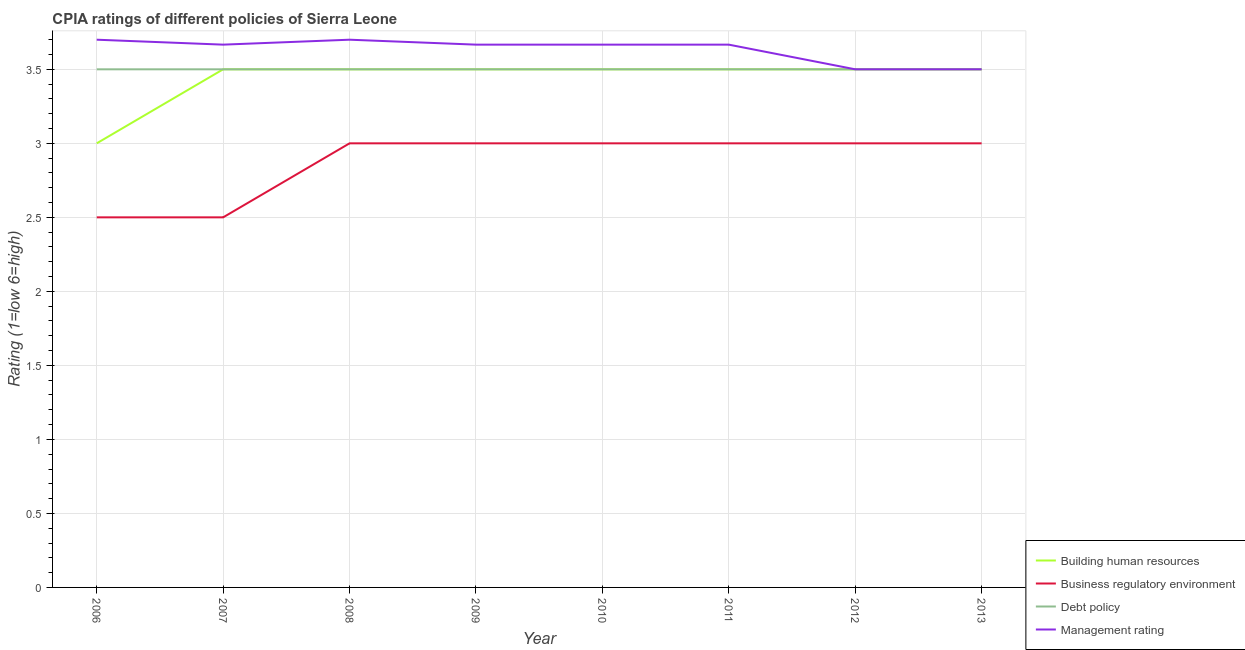How many different coloured lines are there?
Keep it short and to the point. 4. Does the line corresponding to cpia rating of business regulatory environment intersect with the line corresponding to cpia rating of debt policy?
Keep it short and to the point. No. Across all years, what is the maximum cpia rating of debt policy?
Ensure brevity in your answer.  3.5. In which year was the cpia rating of business regulatory environment minimum?
Offer a terse response. 2006. What is the difference between the cpia rating of management in 2009 and the cpia rating of business regulatory environment in 2007?
Provide a short and direct response. 1.17. What is the average cpia rating of management per year?
Your answer should be very brief. 3.63. What is the ratio of the cpia rating of business regulatory environment in 2007 to that in 2011?
Offer a terse response. 0.83. Is the cpia rating of debt policy in 2006 less than that in 2009?
Provide a succinct answer. No. Is the difference between the cpia rating of management in 2010 and 2012 greater than the difference between the cpia rating of debt policy in 2010 and 2012?
Keep it short and to the point. Yes. What is the difference between the highest and the second highest cpia rating of building human resources?
Your answer should be very brief. 0. What is the difference between the highest and the lowest cpia rating of management?
Ensure brevity in your answer.  0.2. Is the sum of the cpia rating of business regulatory environment in 2006 and 2011 greater than the maximum cpia rating of building human resources across all years?
Offer a terse response. Yes. Is it the case that in every year, the sum of the cpia rating of building human resources and cpia rating of business regulatory environment is greater than the cpia rating of debt policy?
Your response must be concise. Yes. Is the cpia rating of business regulatory environment strictly greater than the cpia rating of building human resources over the years?
Your response must be concise. No. Is the cpia rating of business regulatory environment strictly less than the cpia rating of building human resources over the years?
Provide a short and direct response. Yes. How many years are there in the graph?
Your answer should be very brief. 8. Are the values on the major ticks of Y-axis written in scientific E-notation?
Give a very brief answer. No. How many legend labels are there?
Your answer should be very brief. 4. How are the legend labels stacked?
Offer a terse response. Vertical. What is the title of the graph?
Give a very brief answer. CPIA ratings of different policies of Sierra Leone. Does "Belgium" appear as one of the legend labels in the graph?
Provide a succinct answer. No. What is the label or title of the X-axis?
Provide a short and direct response. Year. What is the label or title of the Y-axis?
Provide a succinct answer. Rating (1=low 6=high). What is the Rating (1=low 6=high) of Business regulatory environment in 2006?
Offer a terse response. 2.5. What is the Rating (1=low 6=high) in Management rating in 2006?
Make the answer very short. 3.7. What is the Rating (1=low 6=high) in Business regulatory environment in 2007?
Offer a terse response. 2.5. What is the Rating (1=low 6=high) of Management rating in 2007?
Give a very brief answer. 3.67. What is the Rating (1=low 6=high) of Building human resources in 2008?
Make the answer very short. 3.5. What is the Rating (1=low 6=high) in Business regulatory environment in 2008?
Your answer should be very brief. 3. What is the Rating (1=low 6=high) in Building human resources in 2009?
Your answer should be compact. 3.5. What is the Rating (1=low 6=high) in Debt policy in 2009?
Your answer should be very brief. 3.5. What is the Rating (1=low 6=high) in Management rating in 2009?
Your answer should be very brief. 3.67. What is the Rating (1=low 6=high) of Management rating in 2010?
Give a very brief answer. 3.67. What is the Rating (1=low 6=high) in Business regulatory environment in 2011?
Give a very brief answer. 3. What is the Rating (1=low 6=high) of Debt policy in 2011?
Provide a succinct answer. 3.5. What is the Rating (1=low 6=high) of Management rating in 2011?
Give a very brief answer. 3.67. What is the Rating (1=low 6=high) in Building human resources in 2012?
Offer a very short reply. 3.5. What is the Rating (1=low 6=high) of Business regulatory environment in 2012?
Offer a terse response. 3. What is the Rating (1=low 6=high) of Debt policy in 2012?
Make the answer very short. 3.5. What is the Rating (1=low 6=high) of Management rating in 2012?
Offer a terse response. 3.5. What is the Rating (1=low 6=high) of Building human resources in 2013?
Provide a short and direct response. 3.5. What is the Rating (1=low 6=high) of Business regulatory environment in 2013?
Give a very brief answer. 3. What is the Rating (1=low 6=high) in Management rating in 2013?
Keep it short and to the point. 3.5. Across all years, what is the maximum Rating (1=low 6=high) in Building human resources?
Make the answer very short. 3.5. Across all years, what is the maximum Rating (1=low 6=high) of Business regulatory environment?
Provide a short and direct response. 3. Across all years, what is the maximum Rating (1=low 6=high) in Debt policy?
Provide a short and direct response. 3.5. Across all years, what is the maximum Rating (1=low 6=high) of Management rating?
Your response must be concise. 3.7. Across all years, what is the minimum Rating (1=low 6=high) of Debt policy?
Offer a very short reply. 3.5. Across all years, what is the minimum Rating (1=low 6=high) in Management rating?
Provide a short and direct response. 3.5. What is the total Rating (1=low 6=high) in Building human resources in the graph?
Your answer should be compact. 27.5. What is the total Rating (1=low 6=high) in Business regulatory environment in the graph?
Keep it short and to the point. 23. What is the total Rating (1=low 6=high) in Debt policy in the graph?
Keep it short and to the point. 28. What is the total Rating (1=low 6=high) in Management rating in the graph?
Your response must be concise. 29.07. What is the difference between the Rating (1=low 6=high) of Business regulatory environment in 2006 and that in 2007?
Give a very brief answer. 0. What is the difference between the Rating (1=low 6=high) in Management rating in 2006 and that in 2007?
Offer a terse response. 0.03. What is the difference between the Rating (1=low 6=high) in Business regulatory environment in 2006 and that in 2008?
Ensure brevity in your answer.  -0.5. What is the difference between the Rating (1=low 6=high) in Management rating in 2006 and that in 2008?
Your answer should be very brief. 0. What is the difference between the Rating (1=low 6=high) of Building human resources in 2006 and that in 2009?
Keep it short and to the point. -0.5. What is the difference between the Rating (1=low 6=high) of Business regulatory environment in 2006 and that in 2009?
Give a very brief answer. -0.5. What is the difference between the Rating (1=low 6=high) in Debt policy in 2006 and that in 2009?
Offer a very short reply. 0. What is the difference between the Rating (1=low 6=high) of Management rating in 2006 and that in 2009?
Make the answer very short. 0.03. What is the difference between the Rating (1=low 6=high) in Building human resources in 2006 and that in 2010?
Give a very brief answer. -0.5. What is the difference between the Rating (1=low 6=high) of Business regulatory environment in 2006 and that in 2010?
Your answer should be very brief. -0.5. What is the difference between the Rating (1=low 6=high) in Business regulatory environment in 2006 and that in 2011?
Offer a terse response. -0.5. What is the difference between the Rating (1=low 6=high) in Management rating in 2006 and that in 2011?
Provide a succinct answer. 0.03. What is the difference between the Rating (1=low 6=high) of Building human resources in 2006 and that in 2012?
Your answer should be compact. -0.5. What is the difference between the Rating (1=low 6=high) of Business regulatory environment in 2006 and that in 2012?
Your response must be concise. -0.5. What is the difference between the Rating (1=low 6=high) in Debt policy in 2006 and that in 2012?
Provide a succinct answer. 0. What is the difference between the Rating (1=low 6=high) in Building human resources in 2006 and that in 2013?
Your answer should be very brief. -0.5. What is the difference between the Rating (1=low 6=high) of Business regulatory environment in 2006 and that in 2013?
Provide a succinct answer. -0.5. What is the difference between the Rating (1=low 6=high) in Management rating in 2006 and that in 2013?
Your answer should be very brief. 0.2. What is the difference between the Rating (1=low 6=high) in Building human resources in 2007 and that in 2008?
Provide a short and direct response. 0. What is the difference between the Rating (1=low 6=high) in Debt policy in 2007 and that in 2008?
Your response must be concise. 0. What is the difference between the Rating (1=low 6=high) in Management rating in 2007 and that in 2008?
Provide a succinct answer. -0.03. What is the difference between the Rating (1=low 6=high) in Building human resources in 2007 and that in 2009?
Offer a terse response. 0. What is the difference between the Rating (1=low 6=high) of Business regulatory environment in 2007 and that in 2009?
Keep it short and to the point. -0.5. What is the difference between the Rating (1=low 6=high) in Building human resources in 2007 and that in 2010?
Your response must be concise. 0. What is the difference between the Rating (1=low 6=high) of Debt policy in 2007 and that in 2010?
Your answer should be very brief. 0. What is the difference between the Rating (1=low 6=high) in Management rating in 2007 and that in 2010?
Your response must be concise. 0. What is the difference between the Rating (1=low 6=high) in Management rating in 2007 and that in 2011?
Make the answer very short. 0. What is the difference between the Rating (1=low 6=high) of Debt policy in 2007 and that in 2012?
Your response must be concise. 0. What is the difference between the Rating (1=low 6=high) in Management rating in 2007 and that in 2012?
Keep it short and to the point. 0.17. What is the difference between the Rating (1=low 6=high) of Business regulatory environment in 2007 and that in 2013?
Your response must be concise. -0.5. What is the difference between the Rating (1=low 6=high) of Building human resources in 2008 and that in 2009?
Your response must be concise. 0. What is the difference between the Rating (1=low 6=high) in Business regulatory environment in 2008 and that in 2009?
Provide a succinct answer. 0. What is the difference between the Rating (1=low 6=high) in Management rating in 2008 and that in 2009?
Provide a short and direct response. 0.03. What is the difference between the Rating (1=low 6=high) in Debt policy in 2008 and that in 2010?
Provide a short and direct response. 0. What is the difference between the Rating (1=low 6=high) in Building human resources in 2008 and that in 2011?
Provide a short and direct response. 0. What is the difference between the Rating (1=low 6=high) in Business regulatory environment in 2008 and that in 2011?
Offer a terse response. 0. What is the difference between the Rating (1=low 6=high) of Management rating in 2008 and that in 2011?
Your answer should be compact. 0.03. What is the difference between the Rating (1=low 6=high) in Business regulatory environment in 2008 and that in 2012?
Keep it short and to the point. 0. What is the difference between the Rating (1=low 6=high) in Building human resources in 2008 and that in 2013?
Your response must be concise. 0. What is the difference between the Rating (1=low 6=high) in Business regulatory environment in 2008 and that in 2013?
Give a very brief answer. 0. What is the difference between the Rating (1=low 6=high) of Management rating in 2008 and that in 2013?
Offer a very short reply. 0.2. What is the difference between the Rating (1=low 6=high) in Building human resources in 2009 and that in 2010?
Give a very brief answer. 0. What is the difference between the Rating (1=low 6=high) of Building human resources in 2009 and that in 2011?
Offer a terse response. 0. What is the difference between the Rating (1=low 6=high) in Debt policy in 2009 and that in 2011?
Provide a short and direct response. 0. What is the difference between the Rating (1=low 6=high) of Management rating in 2009 and that in 2011?
Make the answer very short. 0. What is the difference between the Rating (1=low 6=high) in Building human resources in 2009 and that in 2012?
Ensure brevity in your answer.  0. What is the difference between the Rating (1=low 6=high) in Business regulatory environment in 2009 and that in 2012?
Make the answer very short. 0. What is the difference between the Rating (1=low 6=high) in Management rating in 2009 and that in 2012?
Provide a short and direct response. 0.17. What is the difference between the Rating (1=low 6=high) in Building human resources in 2009 and that in 2013?
Provide a succinct answer. 0. What is the difference between the Rating (1=low 6=high) of Business regulatory environment in 2009 and that in 2013?
Your answer should be very brief. 0. What is the difference between the Rating (1=low 6=high) of Building human resources in 2010 and that in 2011?
Give a very brief answer. 0. What is the difference between the Rating (1=low 6=high) of Business regulatory environment in 2010 and that in 2011?
Ensure brevity in your answer.  0. What is the difference between the Rating (1=low 6=high) of Building human resources in 2010 and that in 2012?
Provide a short and direct response. 0. What is the difference between the Rating (1=low 6=high) in Business regulatory environment in 2010 and that in 2012?
Make the answer very short. 0. What is the difference between the Rating (1=low 6=high) of Building human resources in 2010 and that in 2013?
Your response must be concise. 0. What is the difference between the Rating (1=low 6=high) in Business regulatory environment in 2010 and that in 2013?
Your answer should be very brief. 0. What is the difference between the Rating (1=low 6=high) of Building human resources in 2011 and that in 2012?
Offer a very short reply. 0. What is the difference between the Rating (1=low 6=high) of Business regulatory environment in 2011 and that in 2012?
Provide a succinct answer. 0. What is the difference between the Rating (1=low 6=high) in Debt policy in 2011 and that in 2012?
Your answer should be compact. 0. What is the difference between the Rating (1=low 6=high) in Management rating in 2011 and that in 2012?
Your answer should be very brief. 0.17. What is the difference between the Rating (1=low 6=high) in Building human resources in 2011 and that in 2013?
Provide a short and direct response. 0. What is the difference between the Rating (1=low 6=high) in Business regulatory environment in 2011 and that in 2013?
Make the answer very short. 0. What is the difference between the Rating (1=low 6=high) of Debt policy in 2011 and that in 2013?
Provide a succinct answer. 0. What is the difference between the Rating (1=low 6=high) in Building human resources in 2012 and that in 2013?
Your response must be concise. 0. What is the difference between the Rating (1=low 6=high) in Business regulatory environment in 2012 and that in 2013?
Offer a very short reply. 0. What is the difference between the Rating (1=low 6=high) in Debt policy in 2012 and that in 2013?
Keep it short and to the point. 0. What is the difference between the Rating (1=low 6=high) of Building human resources in 2006 and the Rating (1=low 6=high) of Management rating in 2007?
Your response must be concise. -0.67. What is the difference between the Rating (1=low 6=high) of Business regulatory environment in 2006 and the Rating (1=low 6=high) of Debt policy in 2007?
Ensure brevity in your answer.  -1. What is the difference between the Rating (1=low 6=high) in Business regulatory environment in 2006 and the Rating (1=low 6=high) in Management rating in 2007?
Give a very brief answer. -1.17. What is the difference between the Rating (1=low 6=high) of Building human resources in 2006 and the Rating (1=low 6=high) of Management rating in 2008?
Offer a very short reply. -0.7. What is the difference between the Rating (1=low 6=high) of Business regulatory environment in 2006 and the Rating (1=low 6=high) of Debt policy in 2008?
Offer a terse response. -1. What is the difference between the Rating (1=low 6=high) of Debt policy in 2006 and the Rating (1=low 6=high) of Management rating in 2008?
Make the answer very short. -0.2. What is the difference between the Rating (1=low 6=high) in Building human resources in 2006 and the Rating (1=low 6=high) in Debt policy in 2009?
Offer a terse response. -0.5. What is the difference between the Rating (1=low 6=high) of Building human resources in 2006 and the Rating (1=low 6=high) of Management rating in 2009?
Give a very brief answer. -0.67. What is the difference between the Rating (1=low 6=high) in Business regulatory environment in 2006 and the Rating (1=low 6=high) in Debt policy in 2009?
Keep it short and to the point. -1. What is the difference between the Rating (1=low 6=high) of Business regulatory environment in 2006 and the Rating (1=low 6=high) of Management rating in 2009?
Your answer should be very brief. -1.17. What is the difference between the Rating (1=low 6=high) of Debt policy in 2006 and the Rating (1=low 6=high) of Management rating in 2009?
Ensure brevity in your answer.  -0.17. What is the difference between the Rating (1=low 6=high) in Building human resources in 2006 and the Rating (1=low 6=high) in Debt policy in 2010?
Make the answer very short. -0.5. What is the difference between the Rating (1=low 6=high) in Business regulatory environment in 2006 and the Rating (1=low 6=high) in Management rating in 2010?
Your response must be concise. -1.17. What is the difference between the Rating (1=low 6=high) of Debt policy in 2006 and the Rating (1=low 6=high) of Management rating in 2010?
Offer a very short reply. -0.17. What is the difference between the Rating (1=low 6=high) of Building human resources in 2006 and the Rating (1=low 6=high) of Business regulatory environment in 2011?
Keep it short and to the point. 0. What is the difference between the Rating (1=low 6=high) in Building human resources in 2006 and the Rating (1=low 6=high) in Debt policy in 2011?
Keep it short and to the point. -0.5. What is the difference between the Rating (1=low 6=high) of Business regulatory environment in 2006 and the Rating (1=low 6=high) of Debt policy in 2011?
Keep it short and to the point. -1. What is the difference between the Rating (1=low 6=high) in Business regulatory environment in 2006 and the Rating (1=low 6=high) in Management rating in 2011?
Keep it short and to the point. -1.17. What is the difference between the Rating (1=low 6=high) of Building human resources in 2006 and the Rating (1=low 6=high) of Business regulatory environment in 2012?
Provide a short and direct response. 0. What is the difference between the Rating (1=low 6=high) in Building human resources in 2006 and the Rating (1=low 6=high) in Debt policy in 2012?
Offer a terse response. -0.5. What is the difference between the Rating (1=low 6=high) in Building human resources in 2006 and the Rating (1=low 6=high) in Management rating in 2012?
Offer a very short reply. -0.5. What is the difference between the Rating (1=low 6=high) in Building human resources in 2006 and the Rating (1=low 6=high) in Business regulatory environment in 2013?
Give a very brief answer. 0. What is the difference between the Rating (1=low 6=high) of Building human resources in 2006 and the Rating (1=low 6=high) of Management rating in 2013?
Your answer should be compact. -0.5. What is the difference between the Rating (1=low 6=high) of Business regulatory environment in 2006 and the Rating (1=low 6=high) of Debt policy in 2013?
Provide a succinct answer. -1. What is the difference between the Rating (1=low 6=high) of Business regulatory environment in 2006 and the Rating (1=low 6=high) of Management rating in 2013?
Your response must be concise. -1. What is the difference between the Rating (1=low 6=high) of Debt policy in 2006 and the Rating (1=low 6=high) of Management rating in 2013?
Your answer should be very brief. 0. What is the difference between the Rating (1=low 6=high) of Building human resources in 2007 and the Rating (1=low 6=high) of Debt policy in 2008?
Give a very brief answer. 0. What is the difference between the Rating (1=low 6=high) of Business regulatory environment in 2007 and the Rating (1=low 6=high) of Debt policy in 2008?
Ensure brevity in your answer.  -1. What is the difference between the Rating (1=low 6=high) in Business regulatory environment in 2007 and the Rating (1=low 6=high) in Management rating in 2008?
Give a very brief answer. -1.2. What is the difference between the Rating (1=low 6=high) of Business regulatory environment in 2007 and the Rating (1=low 6=high) of Management rating in 2009?
Make the answer very short. -1.17. What is the difference between the Rating (1=low 6=high) of Building human resources in 2007 and the Rating (1=low 6=high) of Business regulatory environment in 2010?
Your response must be concise. 0.5. What is the difference between the Rating (1=low 6=high) of Business regulatory environment in 2007 and the Rating (1=low 6=high) of Debt policy in 2010?
Ensure brevity in your answer.  -1. What is the difference between the Rating (1=low 6=high) in Business regulatory environment in 2007 and the Rating (1=low 6=high) in Management rating in 2010?
Make the answer very short. -1.17. What is the difference between the Rating (1=low 6=high) of Building human resources in 2007 and the Rating (1=low 6=high) of Business regulatory environment in 2011?
Keep it short and to the point. 0.5. What is the difference between the Rating (1=low 6=high) of Building human resources in 2007 and the Rating (1=low 6=high) of Debt policy in 2011?
Your answer should be very brief. 0. What is the difference between the Rating (1=low 6=high) in Business regulatory environment in 2007 and the Rating (1=low 6=high) in Debt policy in 2011?
Your answer should be compact. -1. What is the difference between the Rating (1=low 6=high) of Business regulatory environment in 2007 and the Rating (1=low 6=high) of Management rating in 2011?
Your answer should be compact. -1.17. What is the difference between the Rating (1=low 6=high) of Debt policy in 2007 and the Rating (1=low 6=high) of Management rating in 2011?
Offer a terse response. -0.17. What is the difference between the Rating (1=low 6=high) of Building human resources in 2007 and the Rating (1=low 6=high) of Business regulatory environment in 2012?
Make the answer very short. 0.5. What is the difference between the Rating (1=low 6=high) in Building human resources in 2007 and the Rating (1=low 6=high) in Debt policy in 2012?
Keep it short and to the point. 0. What is the difference between the Rating (1=low 6=high) of Building human resources in 2007 and the Rating (1=low 6=high) of Business regulatory environment in 2013?
Offer a very short reply. 0.5. What is the difference between the Rating (1=low 6=high) in Building human resources in 2007 and the Rating (1=low 6=high) in Debt policy in 2013?
Provide a succinct answer. 0. What is the difference between the Rating (1=low 6=high) in Building human resources in 2007 and the Rating (1=low 6=high) in Management rating in 2013?
Give a very brief answer. 0. What is the difference between the Rating (1=low 6=high) of Business regulatory environment in 2007 and the Rating (1=low 6=high) of Debt policy in 2013?
Make the answer very short. -1. What is the difference between the Rating (1=low 6=high) of Business regulatory environment in 2007 and the Rating (1=low 6=high) of Management rating in 2013?
Offer a terse response. -1. What is the difference between the Rating (1=low 6=high) of Debt policy in 2007 and the Rating (1=low 6=high) of Management rating in 2013?
Ensure brevity in your answer.  0. What is the difference between the Rating (1=low 6=high) in Building human resources in 2008 and the Rating (1=low 6=high) in Business regulatory environment in 2009?
Offer a terse response. 0.5. What is the difference between the Rating (1=low 6=high) in Building human resources in 2008 and the Rating (1=low 6=high) in Management rating in 2009?
Give a very brief answer. -0.17. What is the difference between the Rating (1=low 6=high) of Business regulatory environment in 2008 and the Rating (1=low 6=high) of Management rating in 2009?
Offer a terse response. -0.67. What is the difference between the Rating (1=low 6=high) of Debt policy in 2008 and the Rating (1=low 6=high) of Management rating in 2010?
Make the answer very short. -0.17. What is the difference between the Rating (1=low 6=high) in Building human resources in 2008 and the Rating (1=low 6=high) in Debt policy in 2011?
Your answer should be compact. 0. What is the difference between the Rating (1=low 6=high) of Business regulatory environment in 2008 and the Rating (1=low 6=high) of Debt policy in 2011?
Provide a succinct answer. -0.5. What is the difference between the Rating (1=low 6=high) in Debt policy in 2008 and the Rating (1=low 6=high) in Management rating in 2011?
Keep it short and to the point. -0.17. What is the difference between the Rating (1=low 6=high) of Building human resources in 2008 and the Rating (1=low 6=high) of Business regulatory environment in 2012?
Your answer should be compact. 0.5. What is the difference between the Rating (1=low 6=high) in Building human resources in 2008 and the Rating (1=low 6=high) in Debt policy in 2012?
Provide a short and direct response. 0. What is the difference between the Rating (1=low 6=high) of Business regulatory environment in 2008 and the Rating (1=low 6=high) of Debt policy in 2012?
Offer a terse response. -0.5. What is the difference between the Rating (1=low 6=high) in Building human resources in 2008 and the Rating (1=low 6=high) in Management rating in 2013?
Make the answer very short. 0. What is the difference between the Rating (1=low 6=high) of Business regulatory environment in 2008 and the Rating (1=low 6=high) of Debt policy in 2013?
Your response must be concise. -0.5. What is the difference between the Rating (1=low 6=high) of Business regulatory environment in 2008 and the Rating (1=low 6=high) of Management rating in 2013?
Offer a very short reply. -0.5. What is the difference between the Rating (1=low 6=high) in Debt policy in 2008 and the Rating (1=low 6=high) in Management rating in 2013?
Offer a very short reply. 0. What is the difference between the Rating (1=low 6=high) of Business regulatory environment in 2009 and the Rating (1=low 6=high) of Debt policy in 2010?
Make the answer very short. -0.5. What is the difference between the Rating (1=low 6=high) of Business regulatory environment in 2009 and the Rating (1=low 6=high) of Management rating in 2010?
Keep it short and to the point. -0.67. What is the difference between the Rating (1=low 6=high) in Debt policy in 2009 and the Rating (1=low 6=high) in Management rating in 2010?
Offer a terse response. -0.17. What is the difference between the Rating (1=low 6=high) of Building human resources in 2009 and the Rating (1=low 6=high) of Management rating in 2011?
Your response must be concise. -0.17. What is the difference between the Rating (1=low 6=high) of Business regulatory environment in 2009 and the Rating (1=low 6=high) of Management rating in 2011?
Provide a short and direct response. -0.67. What is the difference between the Rating (1=low 6=high) in Debt policy in 2009 and the Rating (1=low 6=high) in Management rating in 2011?
Ensure brevity in your answer.  -0.17. What is the difference between the Rating (1=low 6=high) in Building human resources in 2009 and the Rating (1=low 6=high) in Business regulatory environment in 2012?
Offer a terse response. 0.5. What is the difference between the Rating (1=low 6=high) in Building human resources in 2009 and the Rating (1=low 6=high) in Debt policy in 2012?
Offer a terse response. 0. What is the difference between the Rating (1=low 6=high) in Business regulatory environment in 2009 and the Rating (1=low 6=high) in Management rating in 2012?
Provide a short and direct response. -0.5. What is the difference between the Rating (1=low 6=high) in Debt policy in 2009 and the Rating (1=low 6=high) in Management rating in 2012?
Ensure brevity in your answer.  0. What is the difference between the Rating (1=low 6=high) of Business regulatory environment in 2009 and the Rating (1=low 6=high) of Management rating in 2013?
Your answer should be very brief. -0.5. What is the difference between the Rating (1=low 6=high) in Debt policy in 2009 and the Rating (1=low 6=high) in Management rating in 2013?
Keep it short and to the point. 0. What is the difference between the Rating (1=low 6=high) of Building human resources in 2010 and the Rating (1=low 6=high) of Debt policy in 2011?
Your answer should be compact. 0. What is the difference between the Rating (1=low 6=high) in Building human resources in 2010 and the Rating (1=low 6=high) in Management rating in 2011?
Provide a succinct answer. -0.17. What is the difference between the Rating (1=low 6=high) of Business regulatory environment in 2010 and the Rating (1=low 6=high) of Debt policy in 2011?
Your answer should be very brief. -0.5. What is the difference between the Rating (1=low 6=high) of Debt policy in 2010 and the Rating (1=low 6=high) of Management rating in 2011?
Your answer should be very brief. -0.17. What is the difference between the Rating (1=low 6=high) in Building human resources in 2010 and the Rating (1=low 6=high) in Business regulatory environment in 2012?
Your answer should be very brief. 0.5. What is the difference between the Rating (1=low 6=high) of Building human resources in 2010 and the Rating (1=low 6=high) of Debt policy in 2012?
Keep it short and to the point. 0. What is the difference between the Rating (1=low 6=high) of Building human resources in 2010 and the Rating (1=low 6=high) of Management rating in 2012?
Your response must be concise. 0. What is the difference between the Rating (1=low 6=high) of Building human resources in 2010 and the Rating (1=low 6=high) of Debt policy in 2013?
Your answer should be compact. 0. What is the difference between the Rating (1=low 6=high) of Building human resources in 2010 and the Rating (1=low 6=high) of Management rating in 2013?
Offer a terse response. 0. What is the difference between the Rating (1=low 6=high) of Business regulatory environment in 2010 and the Rating (1=low 6=high) of Debt policy in 2013?
Your answer should be very brief. -0.5. What is the difference between the Rating (1=low 6=high) of Building human resources in 2011 and the Rating (1=low 6=high) of Business regulatory environment in 2012?
Provide a short and direct response. 0.5. What is the difference between the Rating (1=low 6=high) in Business regulatory environment in 2011 and the Rating (1=low 6=high) in Debt policy in 2012?
Provide a short and direct response. -0.5. What is the difference between the Rating (1=low 6=high) in Business regulatory environment in 2011 and the Rating (1=low 6=high) in Management rating in 2012?
Offer a very short reply. -0.5. What is the difference between the Rating (1=low 6=high) in Building human resources in 2011 and the Rating (1=low 6=high) in Business regulatory environment in 2013?
Provide a short and direct response. 0.5. What is the difference between the Rating (1=low 6=high) of Business regulatory environment in 2011 and the Rating (1=low 6=high) of Management rating in 2013?
Your answer should be very brief. -0.5. What is the difference between the Rating (1=low 6=high) of Debt policy in 2011 and the Rating (1=low 6=high) of Management rating in 2013?
Offer a terse response. 0. What is the difference between the Rating (1=low 6=high) of Building human resources in 2012 and the Rating (1=low 6=high) of Debt policy in 2013?
Make the answer very short. 0. What is the difference between the Rating (1=low 6=high) of Business regulatory environment in 2012 and the Rating (1=low 6=high) of Debt policy in 2013?
Your response must be concise. -0.5. What is the average Rating (1=low 6=high) of Building human resources per year?
Ensure brevity in your answer.  3.44. What is the average Rating (1=low 6=high) of Business regulatory environment per year?
Give a very brief answer. 2.88. What is the average Rating (1=low 6=high) in Management rating per year?
Give a very brief answer. 3.63. In the year 2006, what is the difference between the Rating (1=low 6=high) of Building human resources and Rating (1=low 6=high) of Business regulatory environment?
Your answer should be very brief. 0.5. In the year 2006, what is the difference between the Rating (1=low 6=high) of Building human resources and Rating (1=low 6=high) of Management rating?
Your response must be concise. -0.7. In the year 2006, what is the difference between the Rating (1=low 6=high) of Business regulatory environment and Rating (1=low 6=high) of Management rating?
Your answer should be very brief. -1.2. In the year 2007, what is the difference between the Rating (1=low 6=high) of Building human resources and Rating (1=low 6=high) of Management rating?
Give a very brief answer. -0.17. In the year 2007, what is the difference between the Rating (1=low 6=high) of Business regulatory environment and Rating (1=low 6=high) of Management rating?
Your answer should be very brief. -1.17. In the year 2007, what is the difference between the Rating (1=low 6=high) in Debt policy and Rating (1=low 6=high) in Management rating?
Provide a short and direct response. -0.17. In the year 2008, what is the difference between the Rating (1=low 6=high) of Building human resources and Rating (1=low 6=high) of Business regulatory environment?
Keep it short and to the point. 0.5. In the year 2008, what is the difference between the Rating (1=low 6=high) of Building human resources and Rating (1=low 6=high) of Management rating?
Give a very brief answer. -0.2. In the year 2008, what is the difference between the Rating (1=low 6=high) in Business regulatory environment and Rating (1=low 6=high) in Management rating?
Your answer should be compact. -0.7. In the year 2008, what is the difference between the Rating (1=low 6=high) of Debt policy and Rating (1=low 6=high) of Management rating?
Your answer should be very brief. -0.2. In the year 2009, what is the difference between the Rating (1=low 6=high) of Building human resources and Rating (1=low 6=high) of Business regulatory environment?
Offer a very short reply. 0.5. In the year 2009, what is the difference between the Rating (1=low 6=high) of Building human resources and Rating (1=low 6=high) of Debt policy?
Provide a succinct answer. 0. In the year 2009, what is the difference between the Rating (1=low 6=high) in Business regulatory environment and Rating (1=low 6=high) in Debt policy?
Offer a very short reply. -0.5. In the year 2009, what is the difference between the Rating (1=low 6=high) of Debt policy and Rating (1=low 6=high) of Management rating?
Offer a very short reply. -0.17. In the year 2010, what is the difference between the Rating (1=low 6=high) in Building human resources and Rating (1=low 6=high) in Debt policy?
Your response must be concise. 0. In the year 2010, what is the difference between the Rating (1=low 6=high) of Building human resources and Rating (1=low 6=high) of Management rating?
Give a very brief answer. -0.17. In the year 2010, what is the difference between the Rating (1=low 6=high) in Business regulatory environment and Rating (1=low 6=high) in Management rating?
Ensure brevity in your answer.  -0.67. In the year 2010, what is the difference between the Rating (1=low 6=high) of Debt policy and Rating (1=low 6=high) of Management rating?
Your response must be concise. -0.17. In the year 2011, what is the difference between the Rating (1=low 6=high) of Building human resources and Rating (1=low 6=high) of Debt policy?
Your answer should be compact. 0. In the year 2011, what is the difference between the Rating (1=low 6=high) of Building human resources and Rating (1=low 6=high) of Management rating?
Your response must be concise. -0.17. In the year 2011, what is the difference between the Rating (1=low 6=high) of Business regulatory environment and Rating (1=low 6=high) of Debt policy?
Provide a short and direct response. -0.5. In the year 2011, what is the difference between the Rating (1=low 6=high) of Debt policy and Rating (1=low 6=high) of Management rating?
Ensure brevity in your answer.  -0.17. In the year 2012, what is the difference between the Rating (1=low 6=high) in Building human resources and Rating (1=low 6=high) in Business regulatory environment?
Your answer should be compact. 0.5. In the year 2012, what is the difference between the Rating (1=low 6=high) in Building human resources and Rating (1=low 6=high) in Debt policy?
Provide a short and direct response. 0. In the year 2012, what is the difference between the Rating (1=low 6=high) in Business regulatory environment and Rating (1=low 6=high) in Debt policy?
Your response must be concise. -0.5. In the year 2012, what is the difference between the Rating (1=low 6=high) of Business regulatory environment and Rating (1=low 6=high) of Management rating?
Provide a short and direct response. -0.5. In the year 2013, what is the difference between the Rating (1=low 6=high) in Building human resources and Rating (1=low 6=high) in Management rating?
Your response must be concise. 0. In the year 2013, what is the difference between the Rating (1=low 6=high) in Business regulatory environment and Rating (1=low 6=high) in Debt policy?
Your response must be concise. -0.5. In the year 2013, what is the difference between the Rating (1=low 6=high) in Business regulatory environment and Rating (1=low 6=high) in Management rating?
Your response must be concise. -0.5. What is the ratio of the Rating (1=low 6=high) in Business regulatory environment in 2006 to that in 2007?
Ensure brevity in your answer.  1. What is the ratio of the Rating (1=low 6=high) in Debt policy in 2006 to that in 2007?
Offer a very short reply. 1. What is the ratio of the Rating (1=low 6=high) in Management rating in 2006 to that in 2007?
Your response must be concise. 1.01. What is the ratio of the Rating (1=low 6=high) of Management rating in 2006 to that in 2008?
Your answer should be compact. 1. What is the ratio of the Rating (1=low 6=high) in Building human resources in 2006 to that in 2009?
Offer a terse response. 0.86. What is the ratio of the Rating (1=low 6=high) of Management rating in 2006 to that in 2009?
Your answer should be very brief. 1.01. What is the ratio of the Rating (1=low 6=high) in Debt policy in 2006 to that in 2010?
Provide a succinct answer. 1. What is the ratio of the Rating (1=low 6=high) of Management rating in 2006 to that in 2010?
Make the answer very short. 1.01. What is the ratio of the Rating (1=low 6=high) in Business regulatory environment in 2006 to that in 2011?
Keep it short and to the point. 0.83. What is the ratio of the Rating (1=low 6=high) of Debt policy in 2006 to that in 2011?
Your response must be concise. 1. What is the ratio of the Rating (1=low 6=high) of Management rating in 2006 to that in 2011?
Keep it short and to the point. 1.01. What is the ratio of the Rating (1=low 6=high) in Building human resources in 2006 to that in 2012?
Your answer should be very brief. 0.86. What is the ratio of the Rating (1=low 6=high) of Business regulatory environment in 2006 to that in 2012?
Give a very brief answer. 0.83. What is the ratio of the Rating (1=low 6=high) of Management rating in 2006 to that in 2012?
Your response must be concise. 1.06. What is the ratio of the Rating (1=low 6=high) of Building human resources in 2006 to that in 2013?
Offer a terse response. 0.86. What is the ratio of the Rating (1=low 6=high) of Management rating in 2006 to that in 2013?
Your response must be concise. 1.06. What is the ratio of the Rating (1=low 6=high) of Management rating in 2007 to that in 2008?
Keep it short and to the point. 0.99. What is the ratio of the Rating (1=low 6=high) of Building human resources in 2007 to that in 2009?
Your response must be concise. 1. What is the ratio of the Rating (1=low 6=high) in Debt policy in 2007 to that in 2009?
Provide a succinct answer. 1. What is the ratio of the Rating (1=low 6=high) of Debt policy in 2007 to that in 2010?
Your response must be concise. 1. What is the ratio of the Rating (1=low 6=high) of Management rating in 2007 to that in 2010?
Your response must be concise. 1. What is the ratio of the Rating (1=low 6=high) of Business regulatory environment in 2007 to that in 2011?
Ensure brevity in your answer.  0.83. What is the ratio of the Rating (1=low 6=high) of Debt policy in 2007 to that in 2011?
Provide a succinct answer. 1. What is the ratio of the Rating (1=low 6=high) of Management rating in 2007 to that in 2011?
Your response must be concise. 1. What is the ratio of the Rating (1=low 6=high) in Building human resources in 2007 to that in 2012?
Give a very brief answer. 1. What is the ratio of the Rating (1=low 6=high) in Business regulatory environment in 2007 to that in 2012?
Make the answer very short. 0.83. What is the ratio of the Rating (1=low 6=high) in Debt policy in 2007 to that in 2012?
Provide a short and direct response. 1. What is the ratio of the Rating (1=low 6=high) of Management rating in 2007 to that in 2012?
Give a very brief answer. 1.05. What is the ratio of the Rating (1=low 6=high) in Building human resources in 2007 to that in 2013?
Keep it short and to the point. 1. What is the ratio of the Rating (1=low 6=high) of Debt policy in 2007 to that in 2013?
Offer a terse response. 1. What is the ratio of the Rating (1=low 6=high) in Management rating in 2007 to that in 2013?
Make the answer very short. 1.05. What is the ratio of the Rating (1=low 6=high) in Building human resources in 2008 to that in 2009?
Your answer should be compact. 1. What is the ratio of the Rating (1=low 6=high) of Business regulatory environment in 2008 to that in 2009?
Provide a short and direct response. 1. What is the ratio of the Rating (1=low 6=high) of Management rating in 2008 to that in 2009?
Give a very brief answer. 1.01. What is the ratio of the Rating (1=low 6=high) of Building human resources in 2008 to that in 2010?
Your answer should be compact. 1. What is the ratio of the Rating (1=low 6=high) of Business regulatory environment in 2008 to that in 2010?
Your response must be concise. 1. What is the ratio of the Rating (1=low 6=high) of Debt policy in 2008 to that in 2010?
Your answer should be compact. 1. What is the ratio of the Rating (1=low 6=high) of Management rating in 2008 to that in 2010?
Provide a short and direct response. 1.01. What is the ratio of the Rating (1=low 6=high) of Business regulatory environment in 2008 to that in 2011?
Provide a succinct answer. 1. What is the ratio of the Rating (1=low 6=high) in Debt policy in 2008 to that in 2011?
Your answer should be very brief. 1. What is the ratio of the Rating (1=low 6=high) of Management rating in 2008 to that in 2011?
Your response must be concise. 1.01. What is the ratio of the Rating (1=low 6=high) of Business regulatory environment in 2008 to that in 2012?
Offer a very short reply. 1. What is the ratio of the Rating (1=low 6=high) in Debt policy in 2008 to that in 2012?
Provide a short and direct response. 1. What is the ratio of the Rating (1=low 6=high) in Management rating in 2008 to that in 2012?
Your answer should be compact. 1.06. What is the ratio of the Rating (1=low 6=high) in Business regulatory environment in 2008 to that in 2013?
Keep it short and to the point. 1. What is the ratio of the Rating (1=low 6=high) of Management rating in 2008 to that in 2013?
Offer a very short reply. 1.06. What is the ratio of the Rating (1=low 6=high) in Business regulatory environment in 2009 to that in 2011?
Your response must be concise. 1. What is the ratio of the Rating (1=low 6=high) in Debt policy in 2009 to that in 2011?
Offer a terse response. 1. What is the ratio of the Rating (1=low 6=high) in Building human resources in 2009 to that in 2012?
Provide a short and direct response. 1. What is the ratio of the Rating (1=low 6=high) of Business regulatory environment in 2009 to that in 2012?
Provide a succinct answer. 1. What is the ratio of the Rating (1=low 6=high) in Management rating in 2009 to that in 2012?
Provide a succinct answer. 1.05. What is the ratio of the Rating (1=low 6=high) in Management rating in 2009 to that in 2013?
Make the answer very short. 1.05. What is the ratio of the Rating (1=low 6=high) of Business regulatory environment in 2010 to that in 2011?
Offer a very short reply. 1. What is the ratio of the Rating (1=low 6=high) in Management rating in 2010 to that in 2011?
Your answer should be compact. 1. What is the ratio of the Rating (1=low 6=high) in Management rating in 2010 to that in 2012?
Make the answer very short. 1.05. What is the ratio of the Rating (1=low 6=high) of Building human resources in 2010 to that in 2013?
Your response must be concise. 1. What is the ratio of the Rating (1=low 6=high) of Business regulatory environment in 2010 to that in 2013?
Ensure brevity in your answer.  1. What is the ratio of the Rating (1=low 6=high) in Debt policy in 2010 to that in 2013?
Give a very brief answer. 1. What is the ratio of the Rating (1=low 6=high) of Management rating in 2010 to that in 2013?
Your answer should be compact. 1.05. What is the ratio of the Rating (1=low 6=high) in Building human resources in 2011 to that in 2012?
Offer a terse response. 1. What is the ratio of the Rating (1=low 6=high) in Business regulatory environment in 2011 to that in 2012?
Give a very brief answer. 1. What is the ratio of the Rating (1=low 6=high) of Management rating in 2011 to that in 2012?
Your response must be concise. 1.05. What is the ratio of the Rating (1=low 6=high) of Management rating in 2011 to that in 2013?
Your answer should be very brief. 1.05. What is the difference between the highest and the second highest Rating (1=low 6=high) in Business regulatory environment?
Your answer should be very brief. 0. What is the difference between the highest and the lowest Rating (1=low 6=high) of Debt policy?
Offer a terse response. 0. 